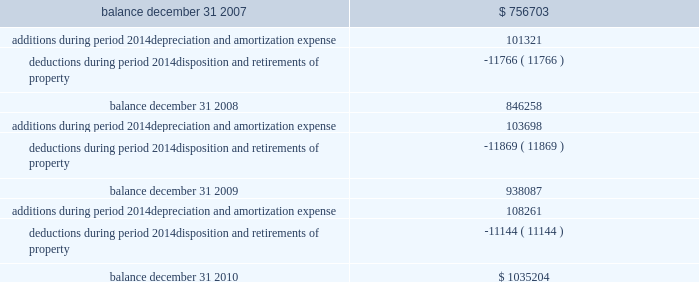Federal realty investment trust schedule iii summary of real estate and accumulated depreciation 2014continued three years ended december 31 , 2010 reconciliation of accumulated depreciation and amortization ( in thousands ) .

How bigger are the additions in comparison with the deductions during 2009? 
Rationale: it is the value of the additions divided by the deductions then multiplied by 100 and then turned into a correct percentage by subtracting 100% .
Computations: (((103698 / 11869) * 100) - 100)
Answer: 773.68776. 